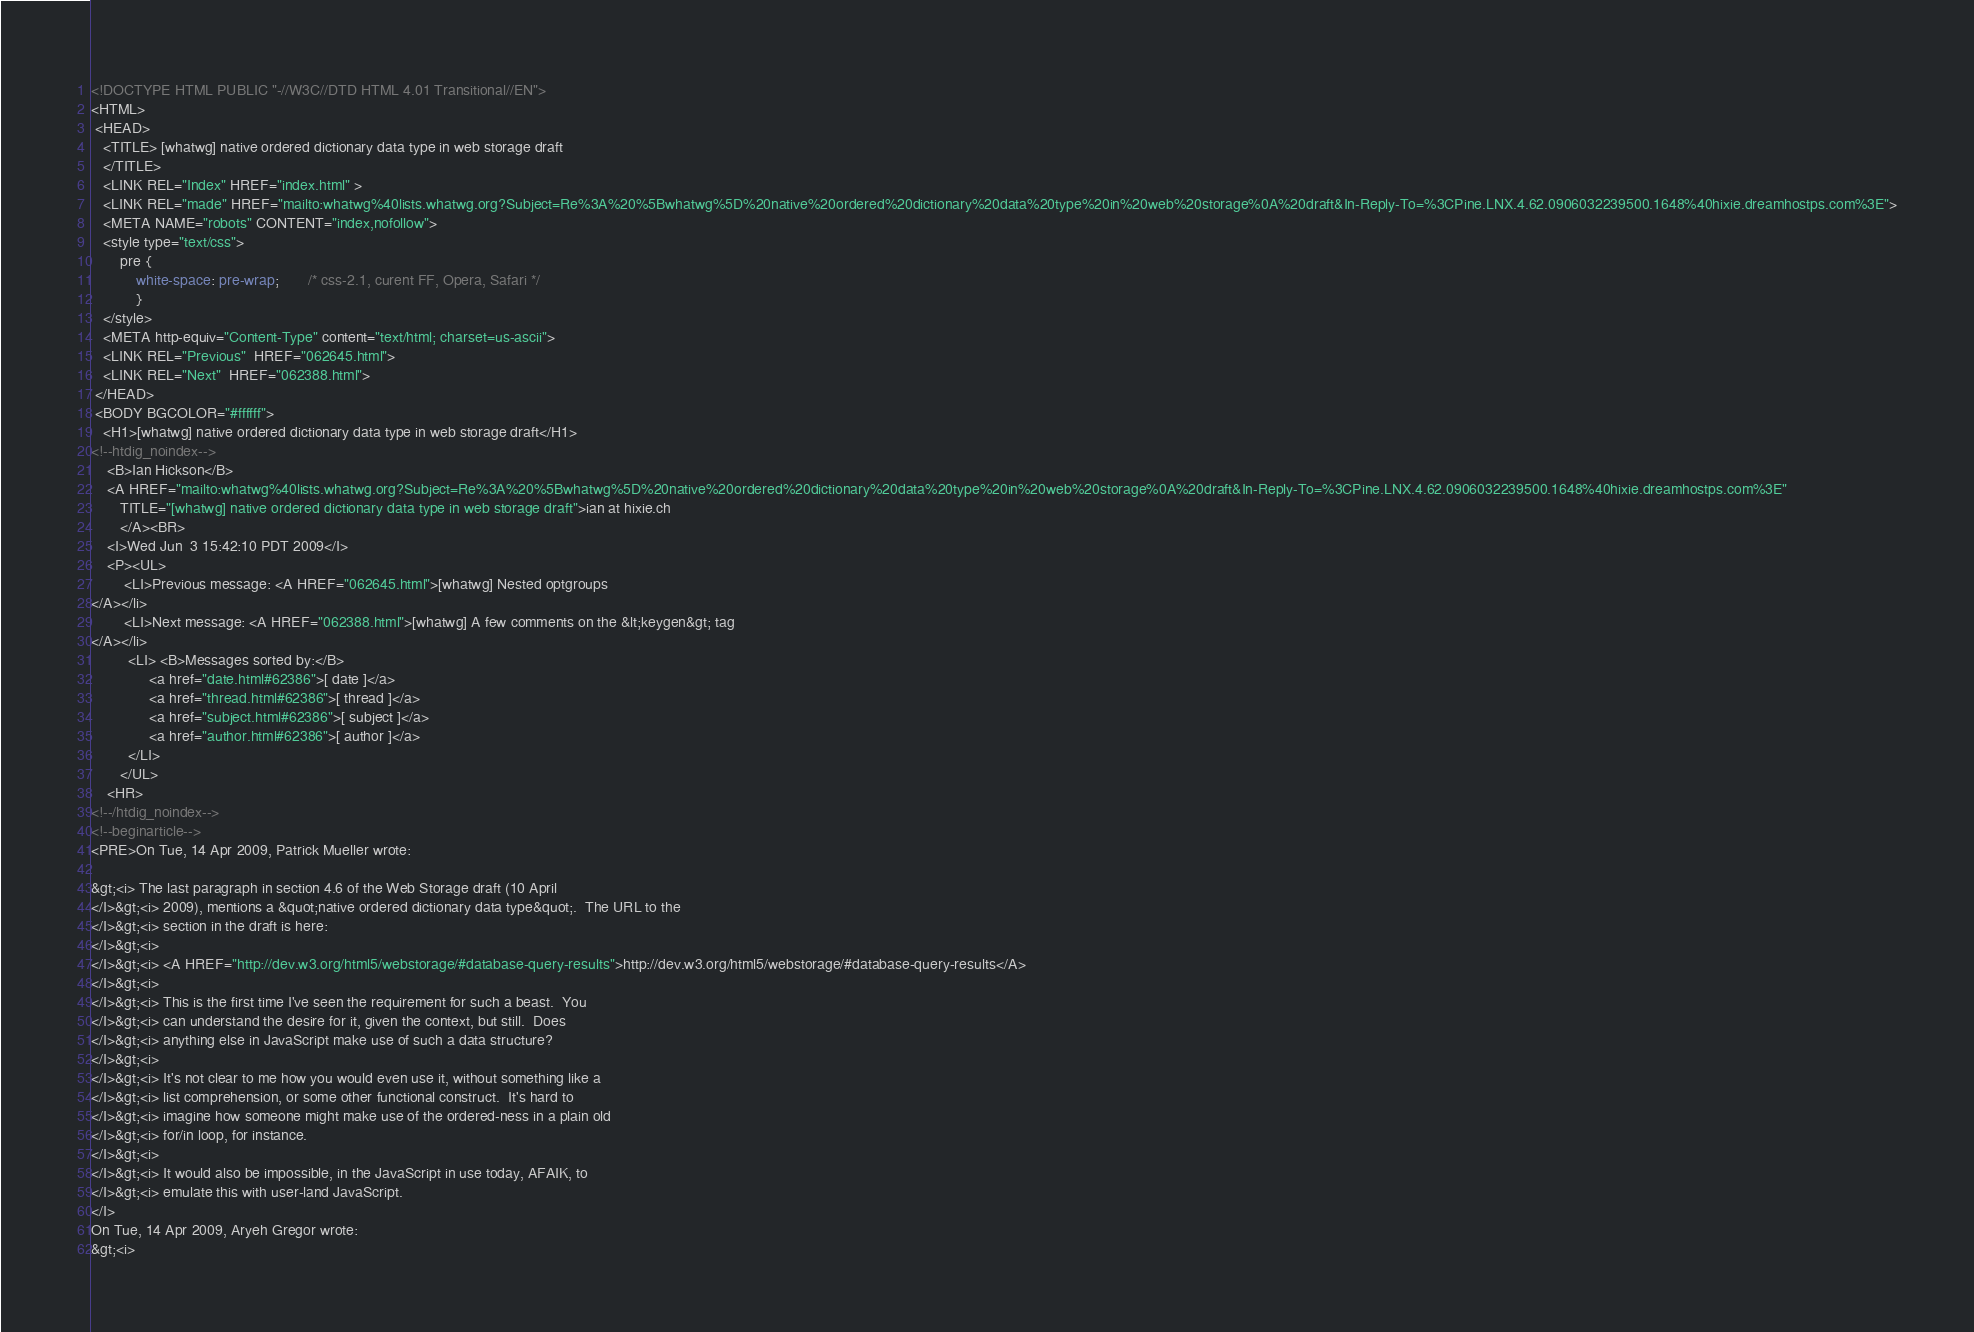<code> <loc_0><loc_0><loc_500><loc_500><_HTML_><!DOCTYPE HTML PUBLIC "-//W3C//DTD HTML 4.01 Transitional//EN">
<HTML>
 <HEAD>
   <TITLE> [whatwg] native ordered dictionary data type in web storage draft
   </TITLE>
   <LINK REL="Index" HREF="index.html" >
   <LINK REL="made" HREF="mailto:whatwg%40lists.whatwg.org?Subject=Re%3A%20%5Bwhatwg%5D%20native%20ordered%20dictionary%20data%20type%20in%20web%20storage%0A%20draft&In-Reply-To=%3CPine.LNX.4.62.0906032239500.1648%40hixie.dreamhostps.com%3E">
   <META NAME="robots" CONTENT="index,nofollow">
   <style type="text/css">
       pre {
           white-space: pre-wrap;       /* css-2.1, curent FF, Opera, Safari */
           }
   </style>
   <META http-equiv="Content-Type" content="text/html; charset=us-ascii">
   <LINK REL="Previous"  HREF="062645.html">
   <LINK REL="Next"  HREF="062388.html">
 </HEAD>
 <BODY BGCOLOR="#ffffff">
   <H1>[whatwg] native ordered dictionary data type in web storage draft</H1>
<!--htdig_noindex-->
    <B>Ian Hickson</B> 
    <A HREF="mailto:whatwg%40lists.whatwg.org?Subject=Re%3A%20%5Bwhatwg%5D%20native%20ordered%20dictionary%20data%20type%20in%20web%20storage%0A%20draft&In-Reply-To=%3CPine.LNX.4.62.0906032239500.1648%40hixie.dreamhostps.com%3E"
       TITLE="[whatwg] native ordered dictionary data type in web storage draft">ian at hixie.ch
       </A><BR>
    <I>Wed Jun  3 15:42:10 PDT 2009</I>
    <P><UL>
        <LI>Previous message: <A HREF="062645.html">[whatwg] Nested optgroups
</A></li>
        <LI>Next message: <A HREF="062388.html">[whatwg] A few comments on the &lt;keygen&gt; tag
</A></li>
         <LI> <B>Messages sorted by:</B> 
              <a href="date.html#62386">[ date ]</a>
              <a href="thread.html#62386">[ thread ]</a>
              <a href="subject.html#62386">[ subject ]</a>
              <a href="author.html#62386">[ author ]</a>
         </LI>
       </UL>
    <HR>  
<!--/htdig_noindex-->
<!--beginarticle-->
<PRE>On Tue, 14 Apr 2009, Patrick Mueller wrote:

&gt;<i> The last paragraph in section 4.6 of the Web Storage draft (10 April 
</I>&gt;<i> 2009), mentions a &quot;native ordered dictionary data type&quot;.  The URL to the 
</I>&gt;<i> section in the draft is here:
</I>&gt;<i> 
</I>&gt;<i> <A HREF="http://dev.w3.org/html5/webstorage/#database-query-results">http://dev.w3.org/html5/webstorage/#database-query-results</A>
</I>&gt;<i> 
</I>&gt;<i> This is the first time I've seen the requirement for such a beast.  You 
</I>&gt;<i> can understand the desire for it, given the context, but still.  Does 
</I>&gt;<i> anything else in JavaScript make use of such a data structure?
</I>&gt;<i>
</I>&gt;<i> It's not clear to me how you would even use it, without something like a 
</I>&gt;<i> list comprehension, or some other functional construct.  It's hard to 
</I>&gt;<i> imagine how someone might make use of the ordered-ness in a plain old 
</I>&gt;<i> for/in loop, for instance.
</I>&gt;<i> 
</I>&gt;<i> It would also be impossible, in the JavaScript in use today, AFAIK, to 
</I>&gt;<i> emulate this with user-land JavaScript.
</I>
On Tue, 14 Apr 2009, Aryeh Gregor wrote:
&gt;<i> </code> 